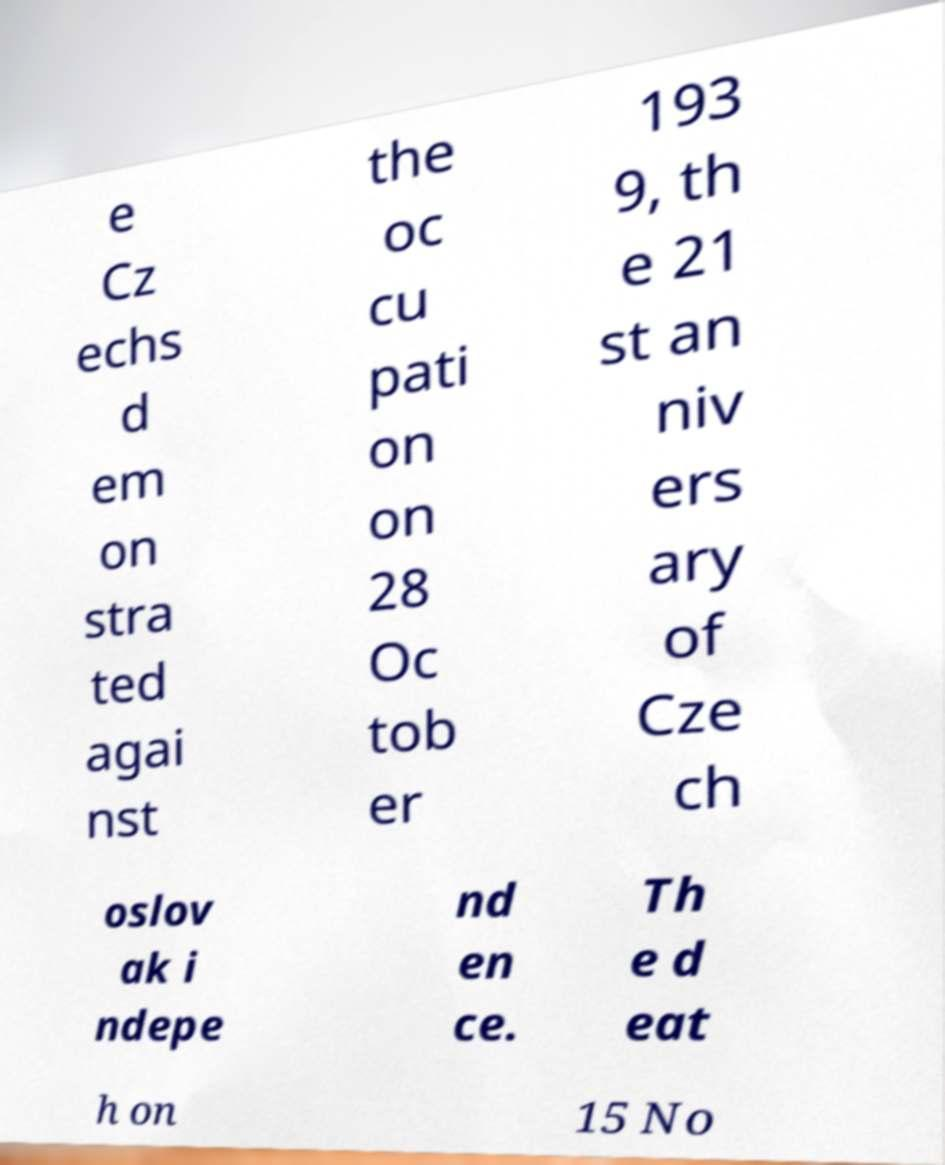Could you extract and type out the text from this image? e Cz echs d em on stra ted agai nst the oc cu pati on on 28 Oc tob er 193 9, th e 21 st an niv ers ary of Cze ch oslov ak i ndepe nd en ce. Th e d eat h on 15 No 